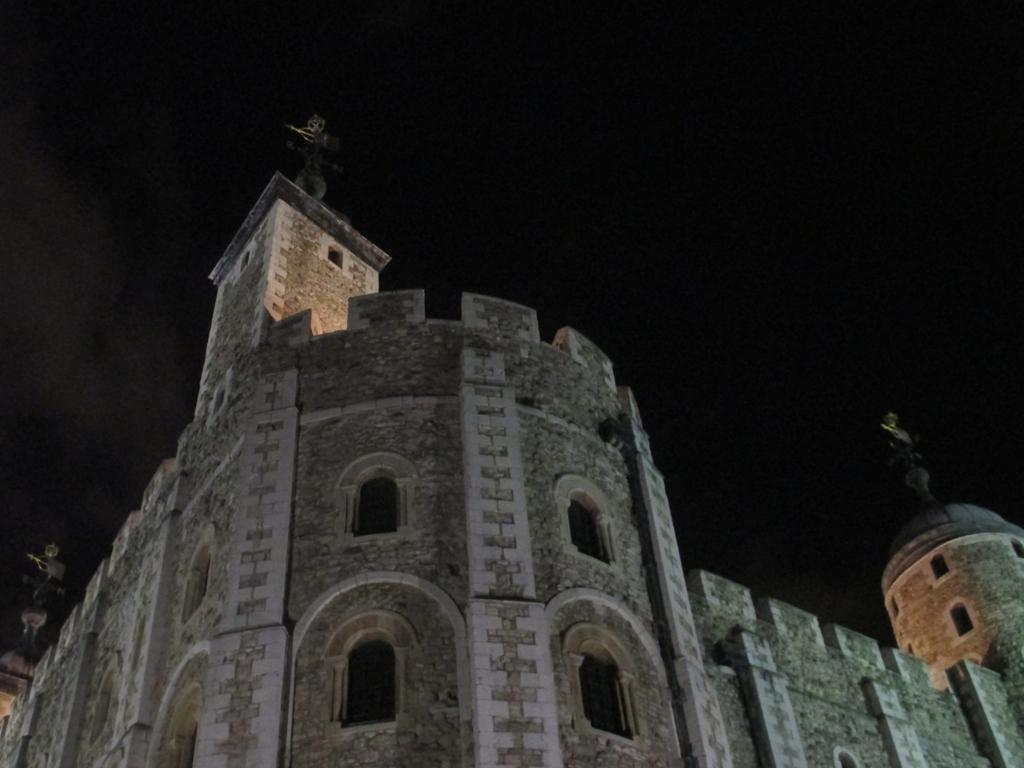What is the main structure in the image? There is a huge fort in the image. What feature can be seen on the fort? The fort has windows. What can be seen in the background of the image? The sky is dark in the background of the image. What type of disease is being treated at the fort in the image? There is no indication of a disease or any medical treatment in the image; it features a fort with windows and a dark sky in the background. 